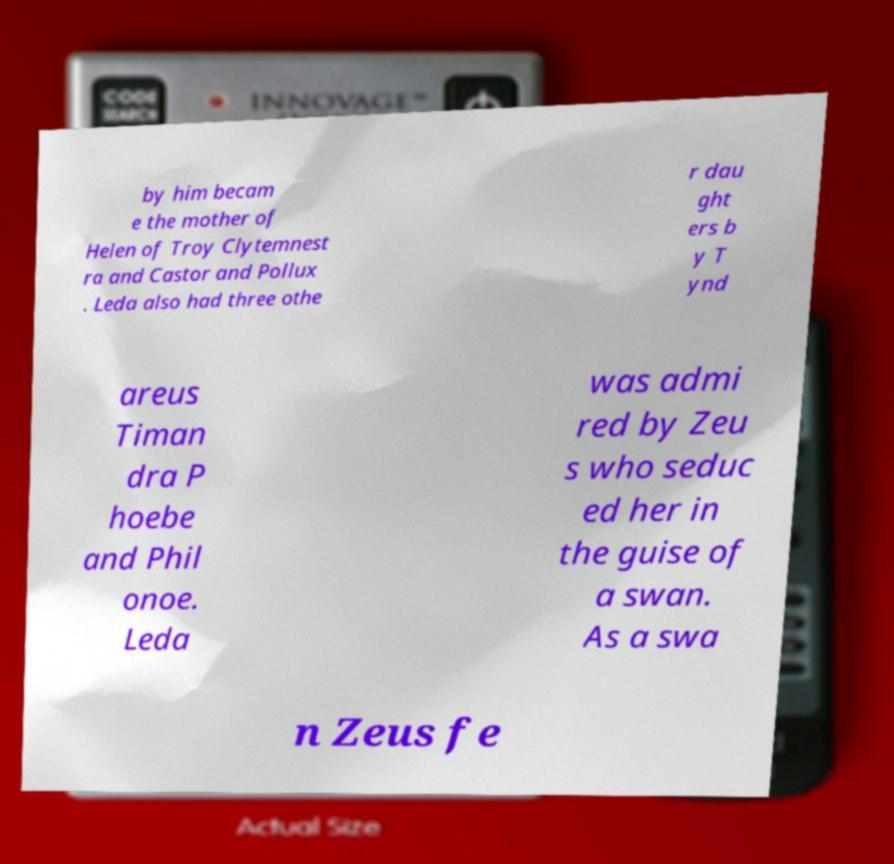Can you read and provide the text displayed in the image?This photo seems to have some interesting text. Can you extract and type it out for me? by him becam e the mother of Helen of Troy Clytemnest ra and Castor and Pollux . Leda also had three othe r dau ght ers b y T ynd areus Timan dra P hoebe and Phil onoe. Leda was admi red by Zeu s who seduc ed her in the guise of a swan. As a swa n Zeus fe 